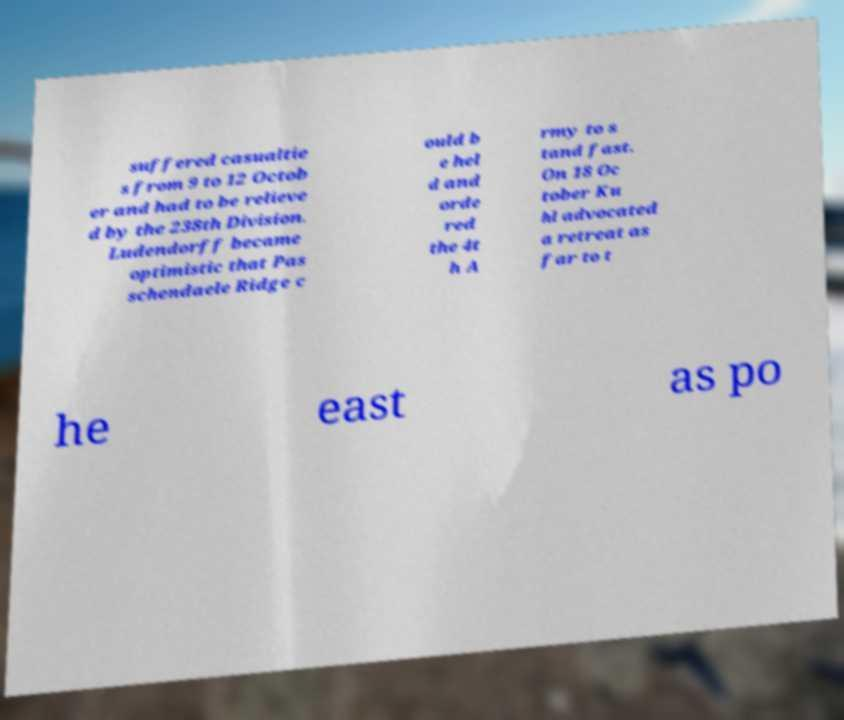Can you accurately transcribe the text from the provided image for me? suffered casualtie s from 9 to 12 Octob er and had to be relieve d by the 238th Division. Ludendorff became optimistic that Pas schendaele Ridge c ould b e hel d and orde red the 4t h A rmy to s tand fast. On 18 Oc tober Ku hl advocated a retreat as far to t he east as po 